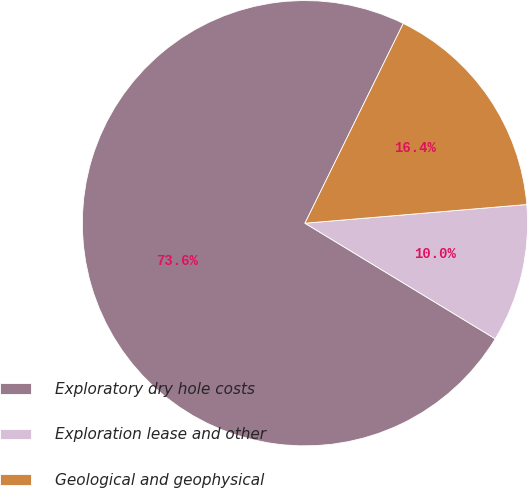Convert chart to OTSL. <chart><loc_0><loc_0><loc_500><loc_500><pie_chart><fcel>Exploratory dry hole costs<fcel>Exploration lease and other<fcel>Geological and geophysical<nl><fcel>73.59%<fcel>10.03%<fcel>16.38%<nl></chart> 